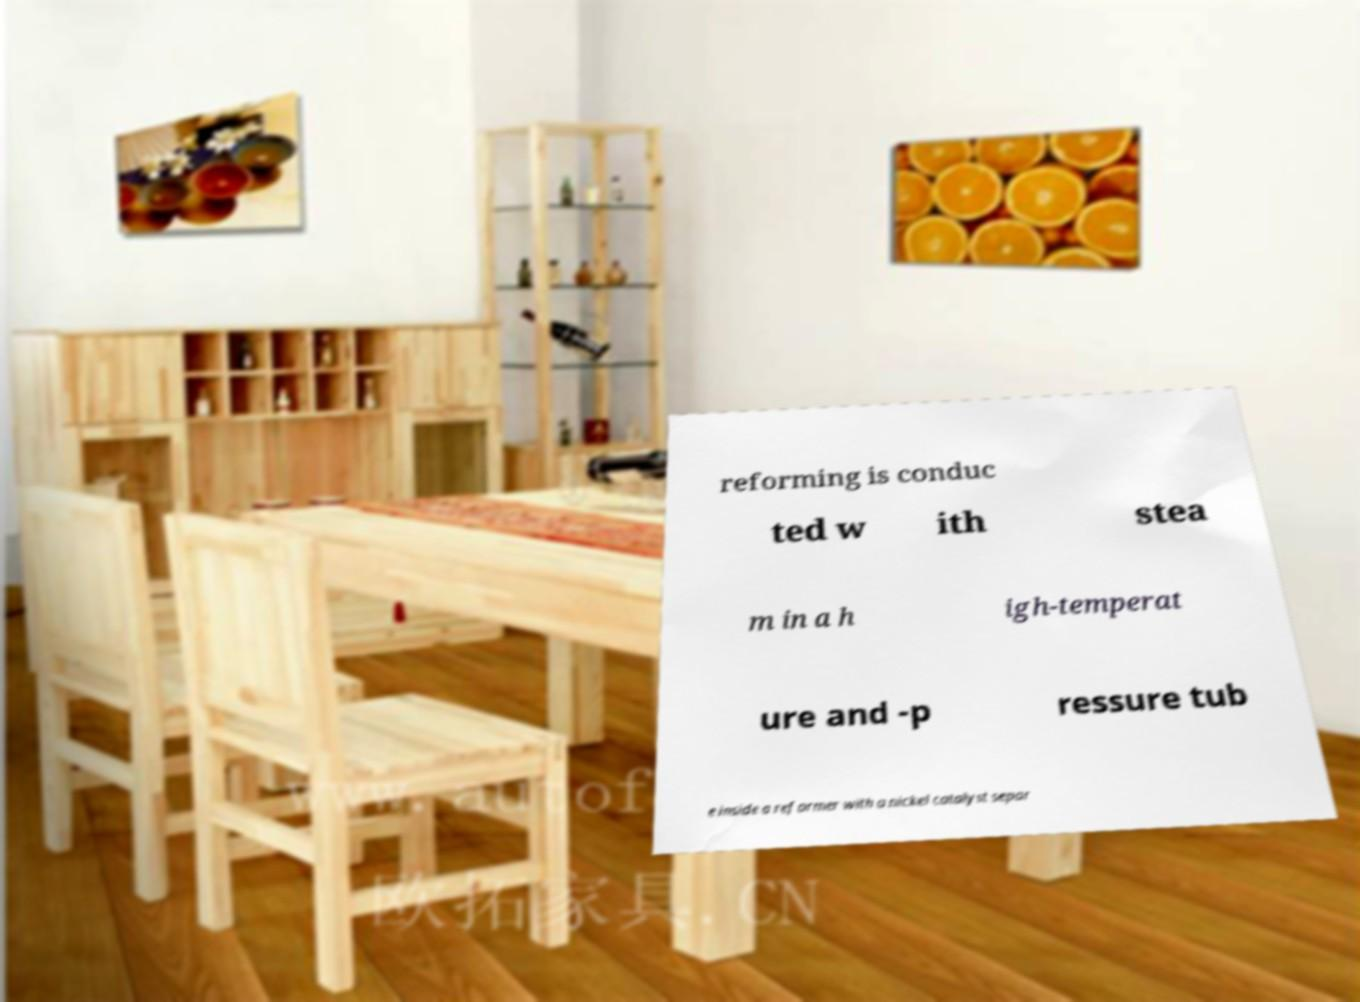There's text embedded in this image that I need extracted. Can you transcribe it verbatim? reforming is conduc ted w ith stea m in a h igh-temperat ure and -p ressure tub e inside a reformer with a nickel catalyst separ 